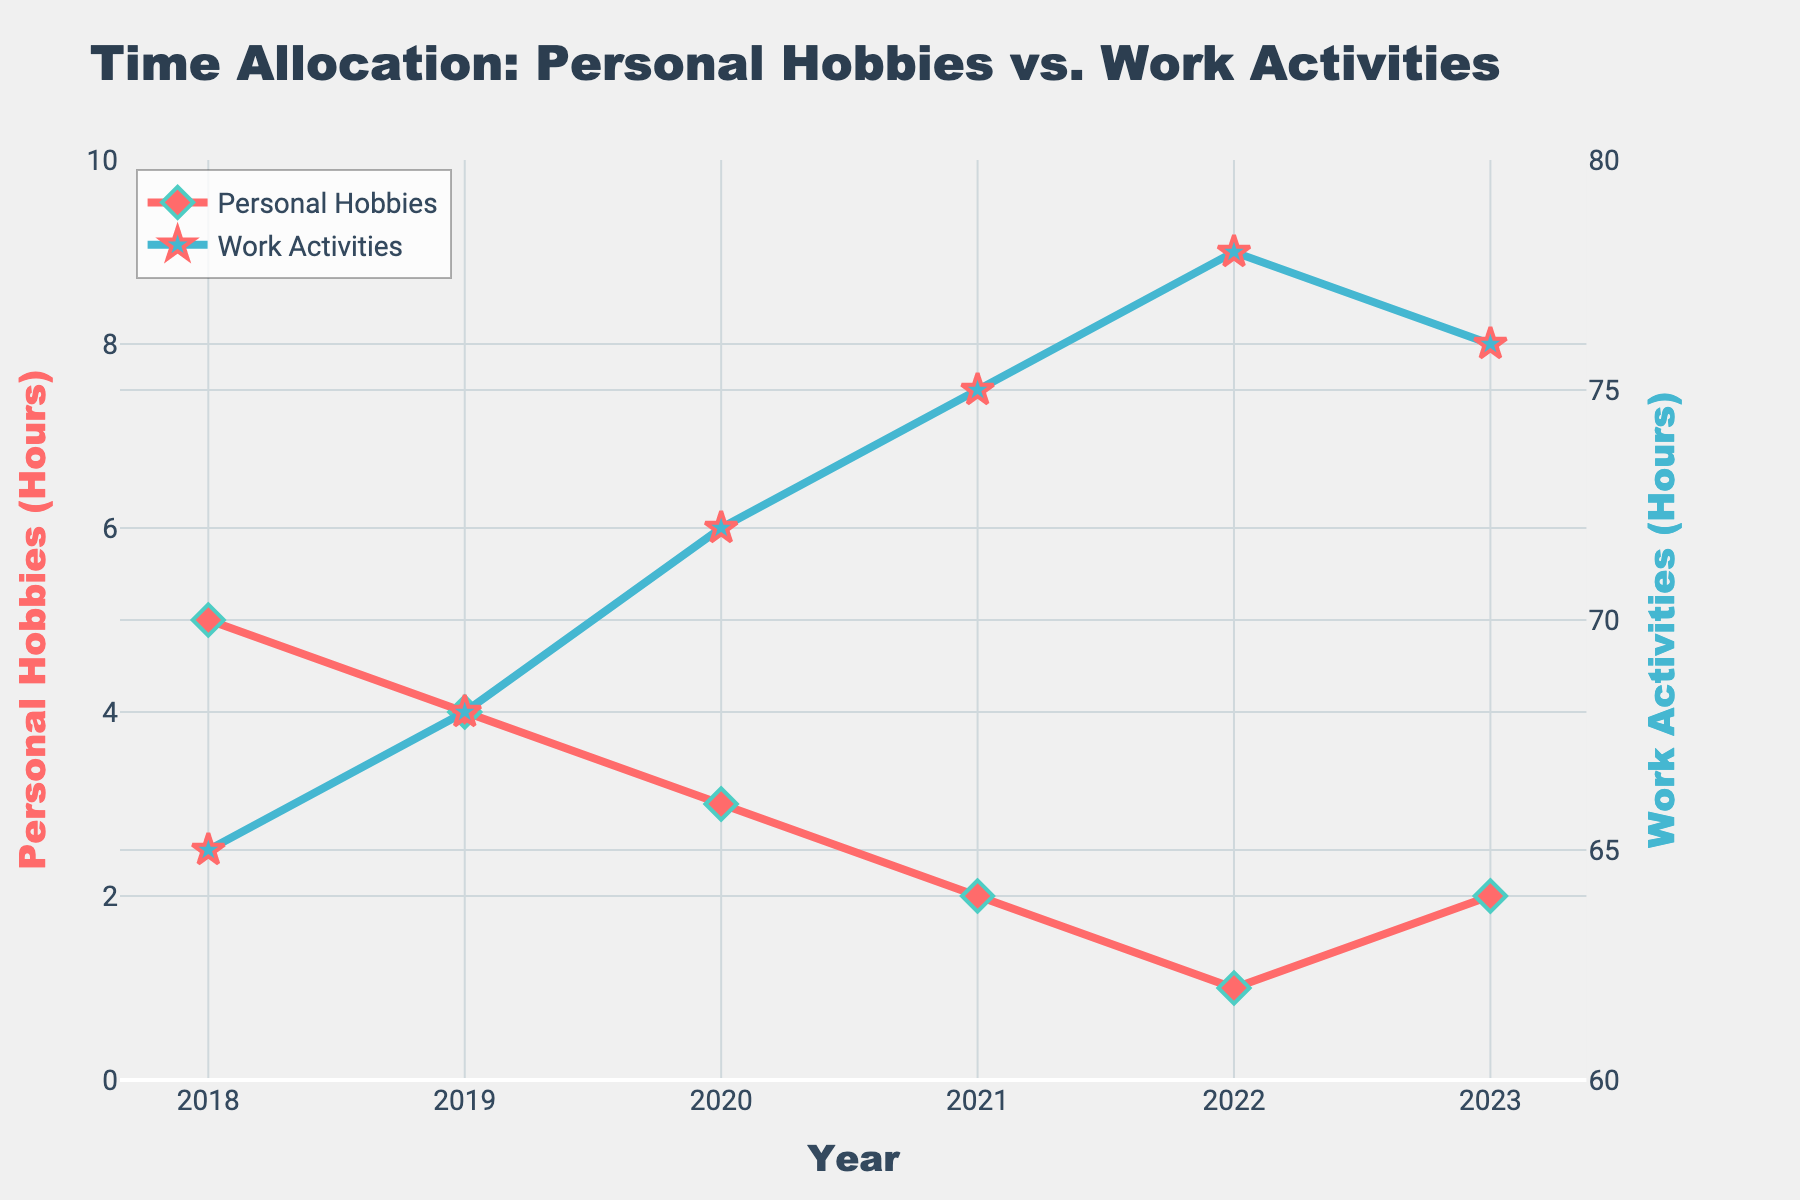How did the number of hours spent on personal hobbies change from 2018 to 2023? The hours spent on personal hobbies decreased over time, starting at 5 hours in 2018, dropping to 1 hour in 2022, and then slightly increasing to 2 hours in 2023.
Answer: Decreased How do the trends of personal hobbies and work activities hours compare over the 5-year period? While the hours spent on personal hobbies decline from 5 hours in 2018 to 1 hour in 2022 before slightly increasing, the hours spent on work activities steadily increase from 65 hours in 2018 to 78 hours in 2022, then slightly decreasing to 76 hours in 2023.
Answer: Inverse trends Which year shows the greatest difference between hours spent on personal hobbies and work activities? The greatest difference occurs in 2022, with 1 hour spent on personal hobbies and 78 hours on work activities, resulting in a difference of 77 hours.
Answer: 2022 What is the average number of hours spent on personal hobbies over the 5-year period? The sum of hours spent on personal hobbies over the period is 5 + 4 + 3 + 2 + 1 + 2 = 17 hours. Dividing by 6 years gives an average of 17/6 ≈ 2.83 hours.
Answer: ≈ 2.83 hours What is the average number of hours spent on work activities over the 5-year period? Adding the work hours from each year: 65 + 68 + 72 + 75 + 78 + 76 = 434 hours, and dividing by 6 years, we get 434/6 ≈ 72.33 hours.
Answer: ≈ 72.33 hours In which year do we see the peak of work-life imbalance, according to the annotation? The annotation on the figure specifically highlights 2023, indicating that work-life imbalance peaks in this year with 2 hours on personal hobbies and 76 hours on work activities.
Answer: 2023 What is the total increase in hours spent on work activities from 2018 to 2022? The hours spent on work activities start at 65 in 2018 and rise to 78 in 2022. The total increase is 78 - 65 = 13 hours.
Answer: 13 hours How many years show an exact 1-hour difference from the previous year in hours spent on personal hobbies? Observing the data, 2018 to 2019 is a decrease of 1 hour (5 - 4), 2019 to 2020 is another decrease of 1 hour (4 - 3), 2020 to 2021 is another decrease of 1 hour (3 - 2), and 2021 to 2022 is another decrease of 1 hour (2 - 1), making it 4 years in total.
Answer: 4 years What patterns can be observed in the lines for personal hobbies and work activities over the 5-year period? The line for personal hobbies is consistently descending with a slight increase in 2023, while the line for work activities is steadily ascending until 2022 and then slightly descends in 2023, indicating opposite trends.
Answer: Opposite trends 